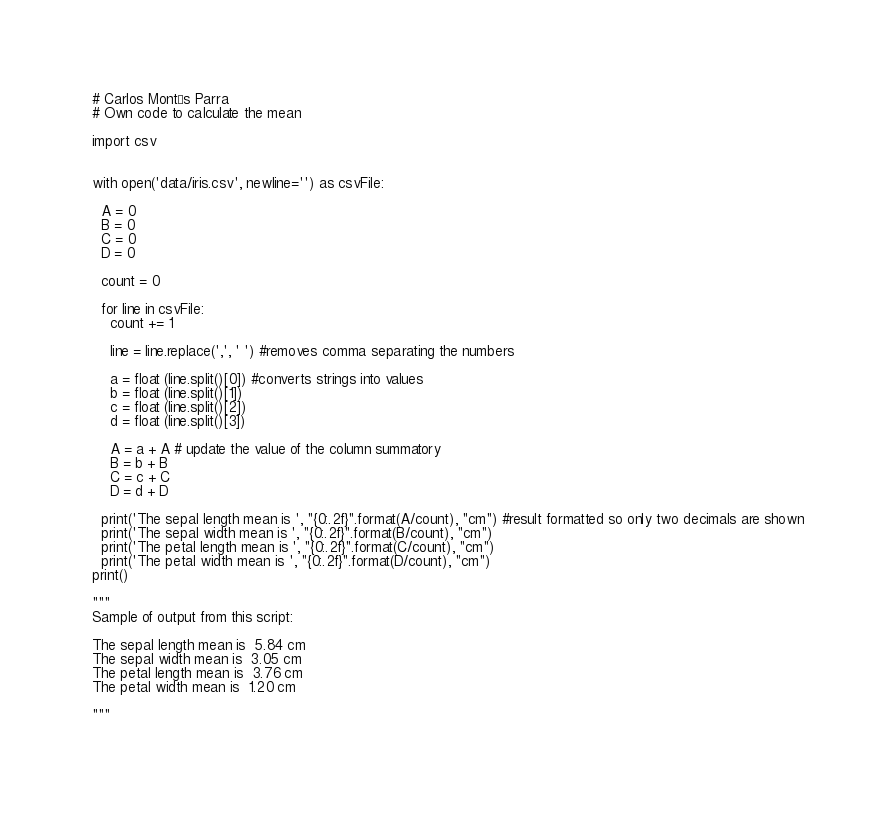<code> <loc_0><loc_0><loc_500><loc_500><_Python_>
# Carlos Montés Parra
# Own code to calculate the mean

import csv


with open('data/iris.csv', newline='') as csvFile:

  A = 0
  B = 0
  C = 0
  D = 0

  count = 0

  for line in csvFile:
    count += 1

    line = line.replace(',', ' ') #removes comma separating the numbers

    a = float (line.split()[0]) #converts strings into values
    b = float (line.split()[1])
    c = float (line.split()[2])
    d = float (line.split()[3])

    A = a + A # update the value of the column summatory 
    B = b + B
    C = c + C
    D = d + D

  print('The sepal length mean is ', "{0:.2f}".format(A/count), "cm") #result formatted so only two decimals are shown
  print('The sepal width mean is ', "{0:.2f}".format(B/count), "cm")
  print('The petal length mean is ', "{0:.2f}".format(C/count), "cm")
  print('The petal width mean is ', "{0:.2f}".format(D/count), "cm")
print()

"""
Sample of output from this script:

The sepal length mean is  5.84 cm
The sepal width mean is  3.05 cm
The petal length mean is  3.76 cm
The petal width mean is  1.20 cm

"""
  </code> 